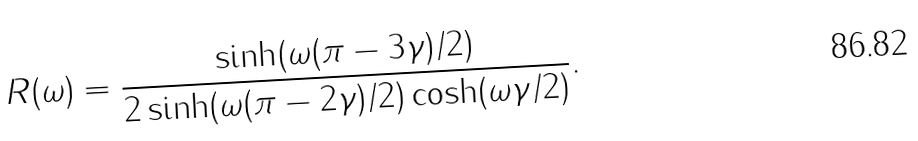Convert formula to latex. <formula><loc_0><loc_0><loc_500><loc_500>R ( \omega ) = \frac { \sinh ( \omega ( \pi - 3 \gamma ) / 2 ) } { 2 \sinh ( \omega ( \pi - 2 \gamma ) / 2 ) \cosh ( \omega \gamma / 2 ) } .</formula> 